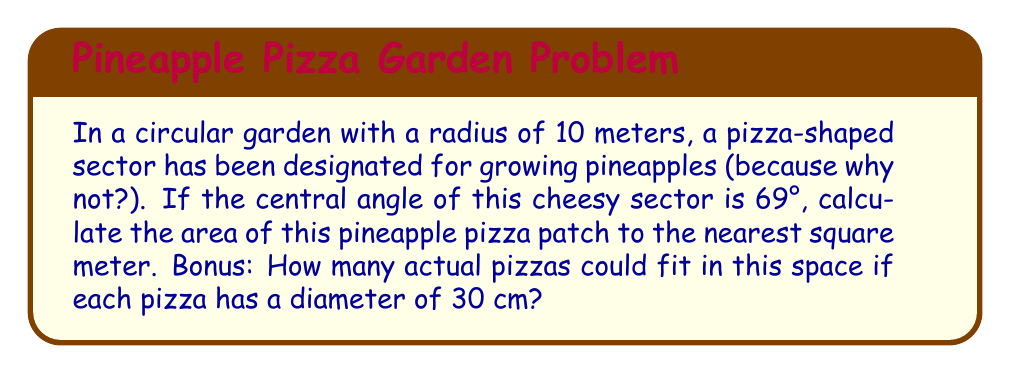Can you answer this question? Let's slice through this problem step by step:

1) The area of a sector in a circle is given by the formula:

   $$A = \frac{\theta}{360°} \pi r^2$$

   Where $\theta$ is the central angle in degrees, and $r$ is the radius.

2) We're given:
   $r = 10$ meters
   $\theta = 69°$

3) Plugging these into our formula:

   $$A = \frac{69°}{360°} \pi (10\text{ m})^2$$

4) Simplify:
   $$A = \frac{69}{360} \pi 100\text{ m}^2$$
   $$A = 0.19167 \pi 100\text{ m}^2$$
   $$A = 19.167 \pi\text{ m}^2$$

5) Calculate:
   $$A \approx 60.21\text{ m}^2$$

6) Rounding to the nearest square meter:
   $$A \approx 60\text{ m}^2$$

Bonus:
7) Area of a 30 cm diameter pizza:
   $$A_{\text{pizza}} = \pi (\frac{30\text{ cm}}{2})^2 = 706.86\text{ cm}^2 = 0.070686\text{ m}^2$$

8) Number of pizzas:
   $$\frac{60\text{ m}^2}{0.070686\text{ m}^2} \approx 848.82$$

   Rounding down: 848 pizzas

[asy]
import geometry;

size(200);
fill(circle((0,0),10), rgb(0.7,0.9,0.7));
fill(arc((0,0),10,0,69), rgb(1,0.8,0.2));
draw(circle((0,0),10));
draw((0,0)--(10,0));
draw((0,0)--(cos(69°)*10,sin(69°)*10));
label("69°", (3,1), fontsize(10));
label("10 m", (5,-0.5), fontsize(10));
dot((0,0));
</asy]
Answer: 60 m². Bonus: 848 pizzas. 